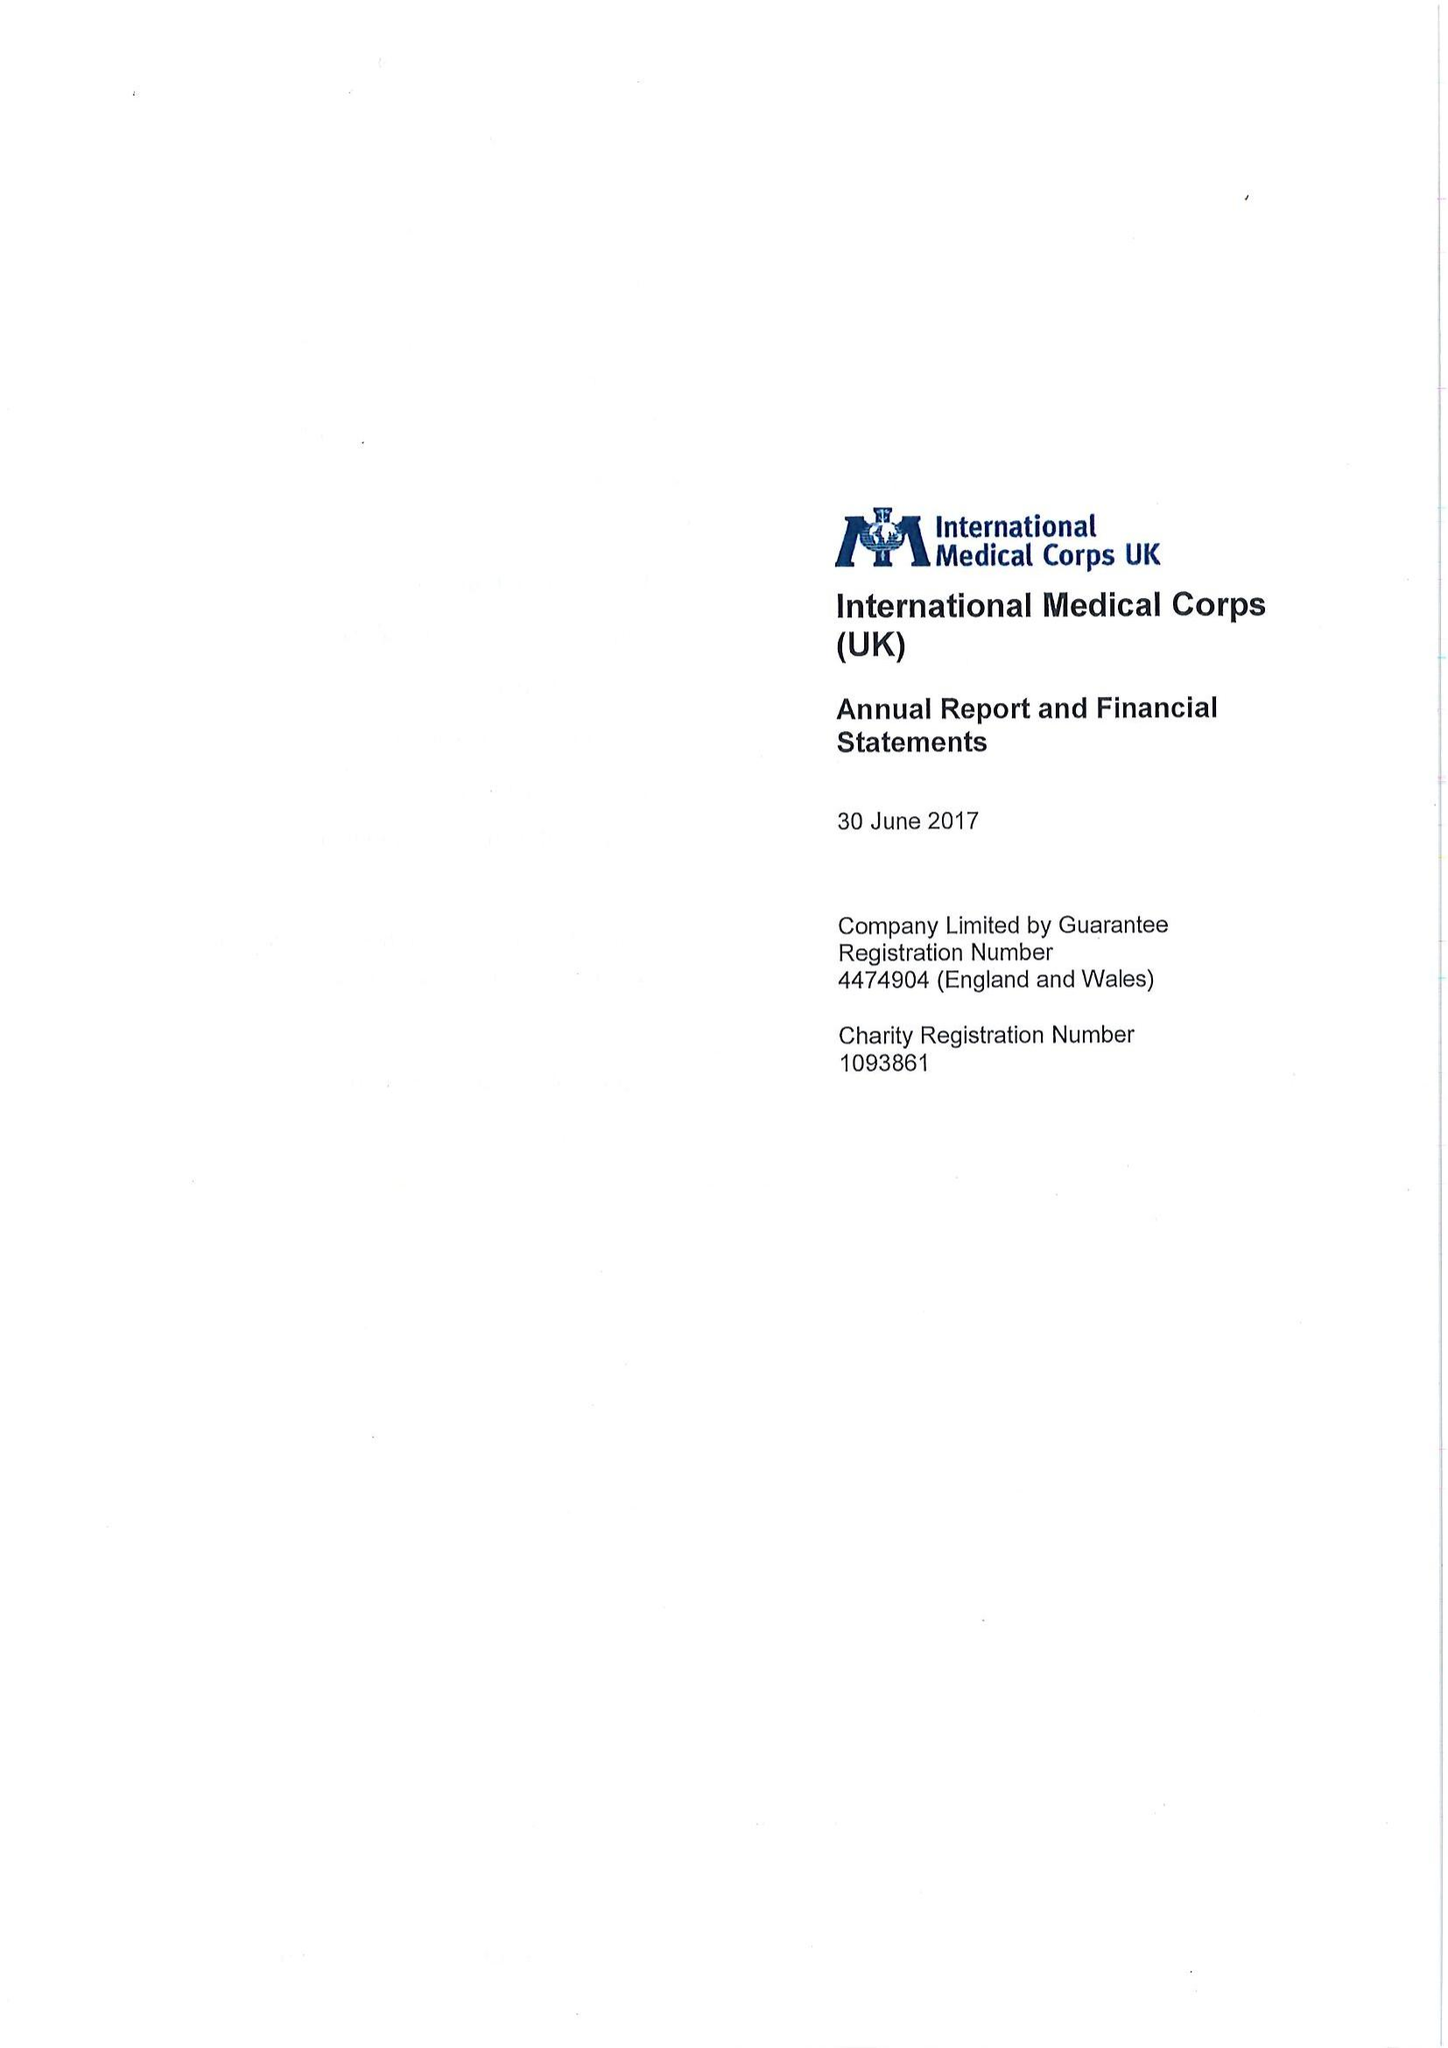What is the value for the address__street_line?
Answer the question using a single word or phrase. 161 MARSH WALL 